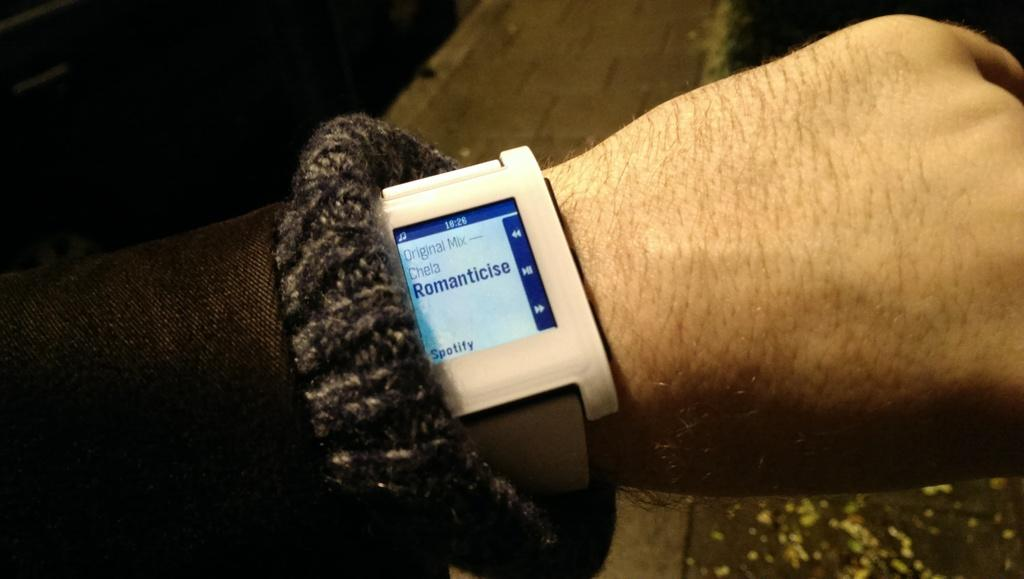<image>
Summarize the visual content of the image. A person listening to a Spotify music playlist on a watch. 